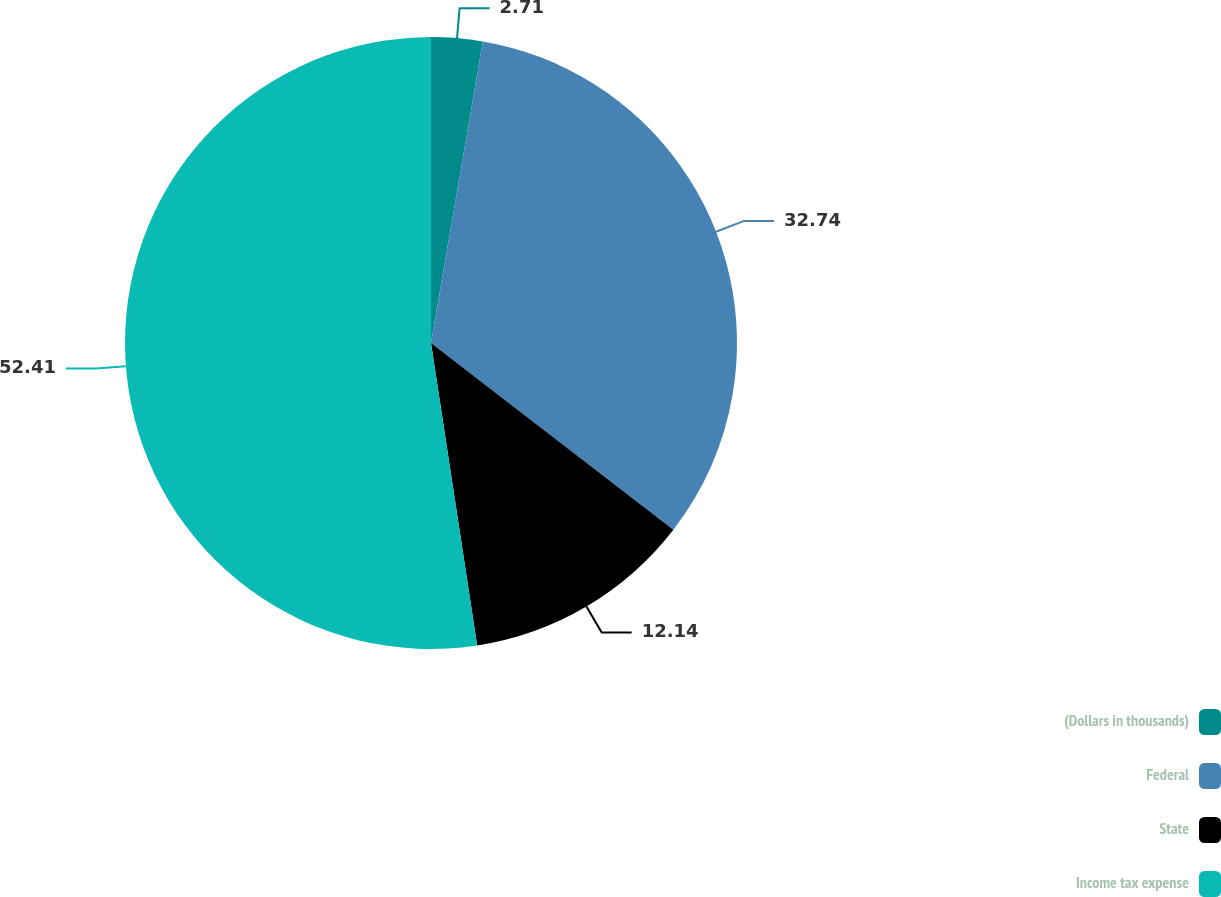<chart> <loc_0><loc_0><loc_500><loc_500><pie_chart><fcel>(Dollars in thousands)<fcel>Federal<fcel>State<fcel>Income tax expense<nl><fcel>2.71%<fcel>32.74%<fcel>12.14%<fcel>52.41%<nl></chart> 